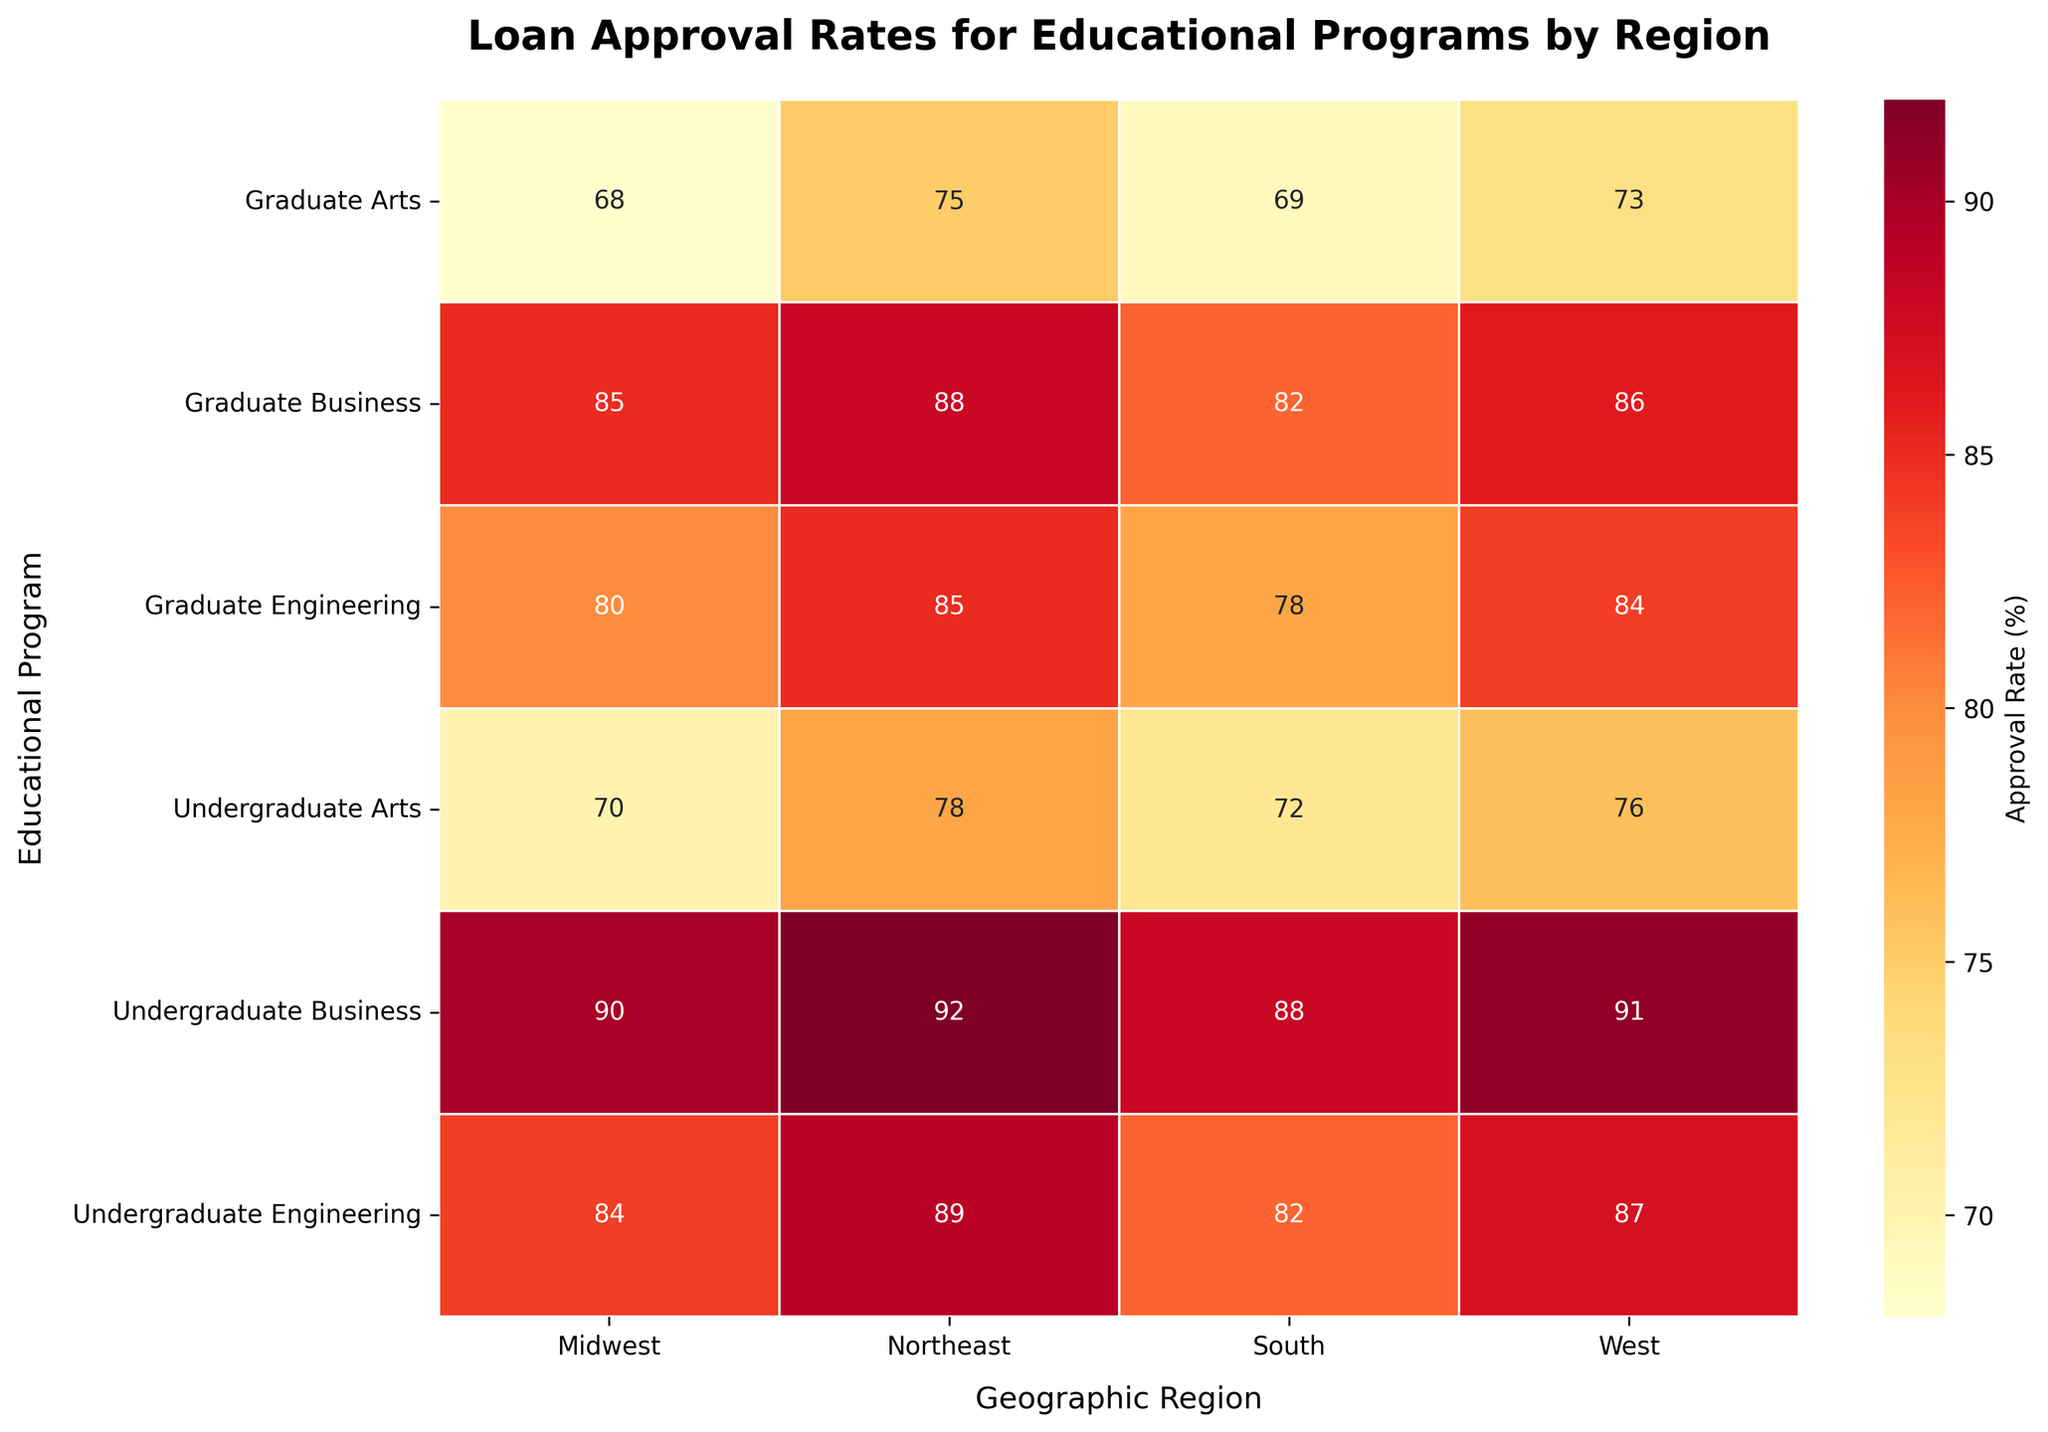What is the title of the heatmap? The title is typically placed at the top of the heatmap and serves to describe the main focus of the visual. In this case, the title summarizes the data being depicted.
Answer: Loan Approval Rates for Educational Programs by Region Which educational program has the highest approval rate in the Northeast region? To find this, look for the highest percentage value under the Northeast column in the heatmap. The highest value represents the highest approval rate.
Answer: Undergraduate Business How does the approval rate of Graduate Arts in the Midwest compare to the South? Locate the approval rates for Graduate Arts in both the Midwest and South regions and compare the two values directly.
Answer: Midwest has a lower approval rate by 1% (68% vs. 69%) What is the range of approval rates for Undergraduate Business programs across all regions? Identify the highest and lowest approval rates for Undergraduate Business in each region, then subtract the lowest value from the highest value to find the range.
Answer: 22 (92% - 70%) Which region has the most uniform approval rates across all educational programs? Observe the heatmap to find the region with the smallest fluctuation in approval rates by comparing maximum and minimum values within each region column.
Answer: Northeast What is the average approval rate for Graduate Engineering programs across all regions? To find the average, sum up all the approval rates listed for Graduate Engineering in each region and divide by the number of regions (4).
Answer: 81.75% (85% + 80% + 78% + 84%) / 4 Which program in which region has the lowest approval rate? Identify the program and region pair with the smallest percentage value in the entire heatmap.
Answer: Graduate Arts in the Midwest Among Undergraduate programs, which has the lowest approval rate and in which region? Look at the approval rates for all Undergraduate programs and find the lowest value, then note the corresponding region.
Answer: Undergraduate Arts in the Midwest What's the difference in approval rate between Graduate Business in the Northeast and South regions? Subtract the approval rate of Graduate Business in the South from that in the Northeast to determine the difference.
Answer: 6% (88% - 82%) Which combination of educational program and region has the highest loan approval rate? Identify the single highest percentage value in the entire heatmap and note the corresponding educational program and region.
Answer: Undergraduate Business in the Northeast 